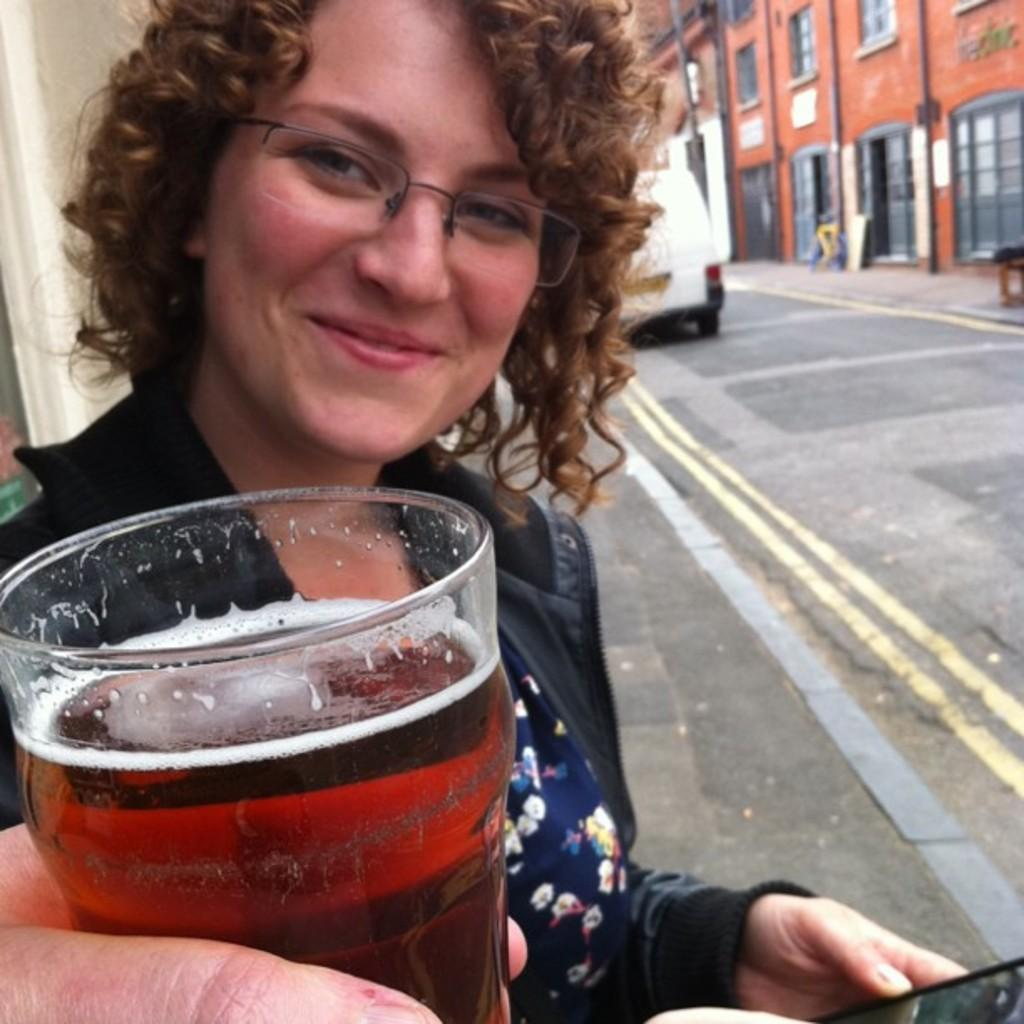Who is present in the image? There is a woman in the image. What is the woman doing in the image? The woman is smiling in the image. What is the woman holding in the image? The woman is holding a mobile in the image. What can be seen in the background of the image? There is a glass, a van, and buildings visible in the background of the image. How many dogs are visible in the image? There are no dogs present in the image. What type of farmer is shown in the image? There is no farmer present in the image. 